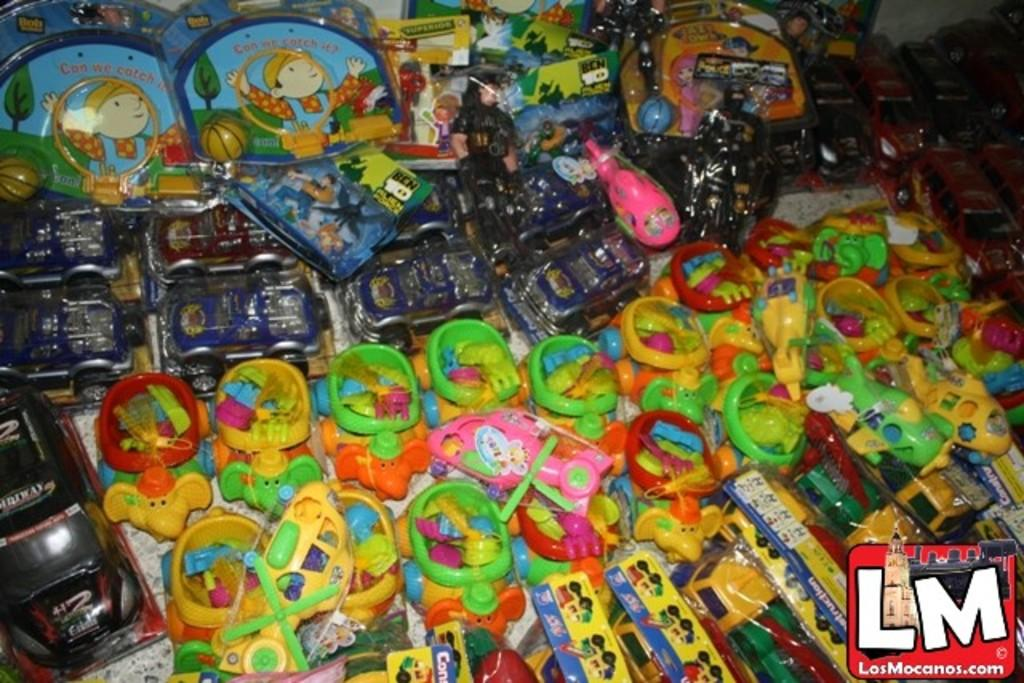What objects can be seen in the image? There are toys in the image. Is there any text or marking in the image? Yes, there is a watermark in the bottom right corner of the image. How many legs can be seen on the toys in the image? There is no information about the number of legs on the toys in the image, nor are there any legs visible in the image. 